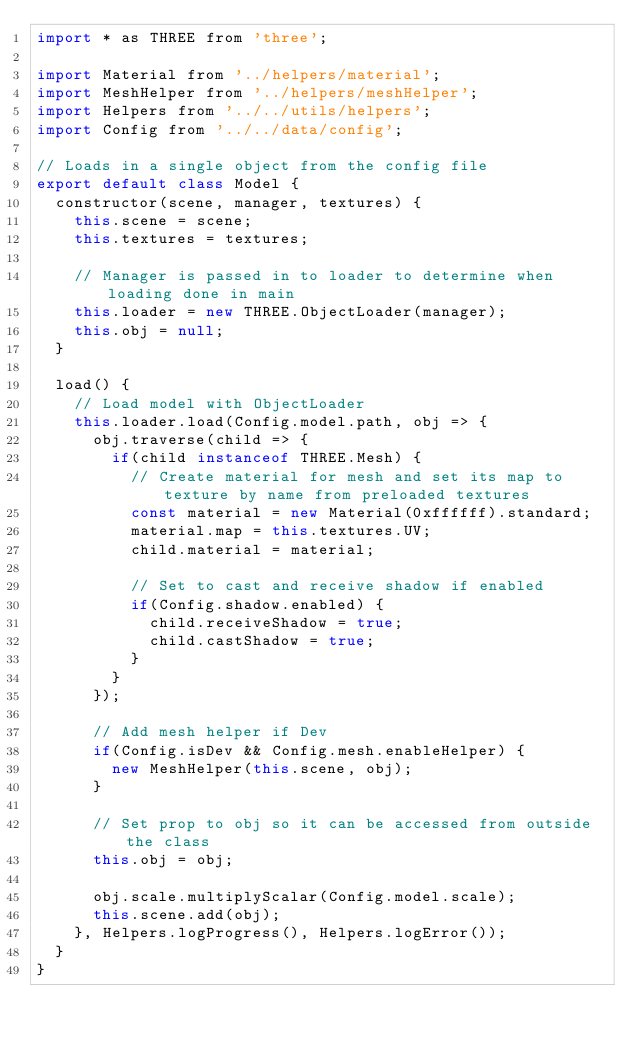Convert code to text. <code><loc_0><loc_0><loc_500><loc_500><_JavaScript_>import * as THREE from 'three';

import Material from '../helpers/material';
import MeshHelper from '../helpers/meshHelper';
import Helpers from '../../utils/helpers';
import Config from '../../data/config';

// Loads in a single object from the config file
export default class Model {
  constructor(scene, manager, textures) {
    this.scene = scene;
    this.textures = textures;

    // Manager is passed in to loader to determine when loading done in main
    this.loader = new THREE.ObjectLoader(manager);
    this.obj = null;
  }

  load() {
    // Load model with ObjectLoader
    this.loader.load(Config.model.path, obj => {
      obj.traverse(child => {
        if(child instanceof THREE.Mesh) {
          // Create material for mesh and set its map to texture by name from preloaded textures
          const material = new Material(0xffffff).standard;
          material.map = this.textures.UV;
          child.material = material;

          // Set to cast and receive shadow if enabled
          if(Config.shadow.enabled) {
            child.receiveShadow = true;
            child.castShadow = true;
          }
        }
      });

      // Add mesh helper if Dev
      if(Config.isDev && Config.mesh.enableHelper) {
        new MeshHelper(this.scene, obj);
      }

      // Set prop to obj so it can be accessed from outside the class
      this.obj = obj;

      obj.scale.multiplyScalar(Config.model.scale);
      this.scene.add(obj);
    }, Helpers.logProgress(), Helpers.logError());
  }
}
</code> 